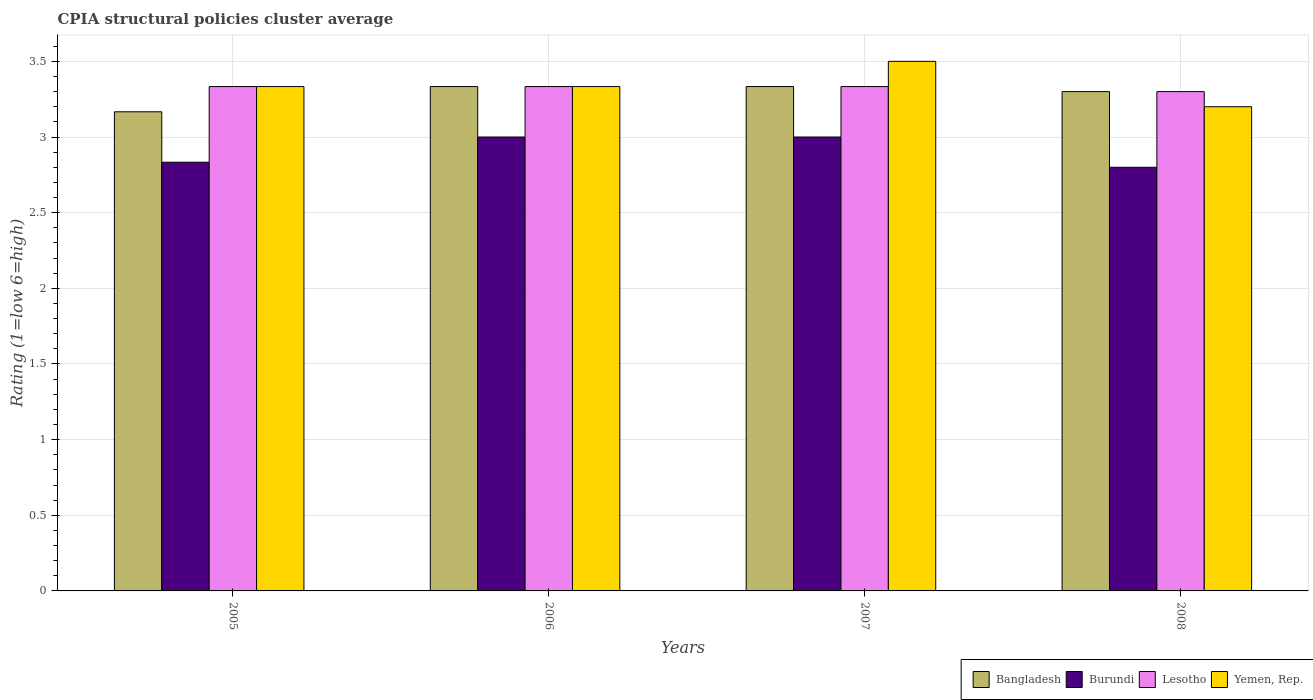How many groups of bars are there?
Make the answer very short. 4. Are the number of bars on each tick of the X-axis equal?
Provide a short and direct response. Yes. How many bars are there on the 3rd tick from the right?
Your answer should be compact. 4. In how many cases, is the number of bars for a given year not equal to the number of legend labels?
Make the answer very short. 0. What is the CPIA rating in Lesotho in 2007?
Keep it short and to the point. 3.33. Across all years, what is the maximum CPIA rating in Bangladesh?
Give a very brief answer. 3.33. Across all years, what is the minimum CPIA rating in Bangladesh?
Offer a terse response. 3.17. In which year was the CPIA rating in Lesotho minimum?
Your answer should be compact. 2008. What is the total CPIA rating in Yemen, Rep. in the graph?
Keep it short and to the point. 13.37. What is the difference between the CPIA rating in Bangladesh in 2005 and that in 2007?
Your response must be concise. -0.17. What is the difference between the CPIA rating in Yemen, Rep. in 2007 and the CPIA rating in Lesotho in 2006?
Offer a very short reply. 0.17. What is the average CPIA rating in Yemen, Rep. per year?
Offer a very short reply. 3.34. What is the ratio of the CPIA rating in Lesotho in 2005 to that in 2008?
Provide a short and direct response. 1.01. What is the difference between the highest and the lowest CPIA rating in Bangladesh?
Your answer should be compact. 0.17. In how many years, is the CPIA rating in Lesotho greater than the average CPIA rating in Lesotho taken over all years?
Offer a terse response. 3. Is the sum of the CPIA rating in Bangladesh in 2005 and 2008 greater than the maximum CPIA rating in Yemen, Rep. across all years?
Keep it short and to the point. Yes. What does the 2nd bar from the left in 2008 represents?
Ensure brevity in your answer.  Burundi. What does the 3rd bar from the right in 2005 represents?
Your response must be concise. Burundi. Is it the case that in every year, the sum of the CPIA rating in Lesotho and CPIA rating in Yemen, Rep. is greater than the CPIA rating in Burundi?
Your answer should be compact. Yes. How many bars are there?
Make the answer very short. 16. Are all the bars in the graph horizontal?
Ensure brevity in your answer.  No. What is the difference between two consecutive major ticks on the Y-axis?
Ensure brevity in your answer.  0.5. Are the values on the major ticks of Y-axis written in scientific E-notation?
Keep it short and to the point. No. Does the graph contain any zero values?
Offer a very short reply. No. Does the graph contain grids?
Your answer should be compact. Yes. How many legend labels are there?
Give a very brief answer. 4. How are the legend labels stacked?
Give a very brief answer. Horizontal. What is the title of the graph?
Your answer should be very brief. CPIA structural policies cluster average. What is the label or title of the X-axis?
Offer a terse response. Years. What is the Rating (1=low 6=high) in Bangladesh in 2005?
Provide a short and direct response. 3.17. What is the Rating (1=low 6=high) of Burundi in 2005?
Provide a short and direct response. 2.83. What is the Rating (1=low 6=high) of Lesotho in 2005?
Your answer should be very brief. 3.33. What is the Rating (1=low 6=high) of Yemen, Rep. in 2005?
Offer a terse response. 3.33. What is the Rating (1=low 6=high) of Bangladesh in 2006?
Provide a short and direct response. 3.33. What is the Rating (1=low 6=high) in Burundi in 2006?
Make the answer very short. 3. What is the Rating (1=low 6=high) of Lesotho in 2006?
Keep it short and to the point. 3.33. What is the Rating (1=low 6=high) in Yemen, Rep. in 2006?
Your answer should be compact. 3.33. What is the Rating (1=low 6=high) in Bangladesh in 2007?
Offer a terse response. 3.33. What is the Rating (1=low 6=high) of Lesotho in 2007?
Ensure brevity in your answer.  3.33. What is the Rating (1=low 6=high) in Burundi in 2008?
Give a very brief answer. 2.8. What is the Rating (1=low 6=high) of Yemen, Rep. in 2008?
Your response must be concise. 3.2. Across all years, what is the maximum Rating (1=low 6=high) of Bangladesh?
Your answer should be very brief. 3.33. Across all years, what is the maximum Rating (1=low 6=high) in Burundi?
Provide a succinct answer. 3. Across all years, what is the maximum Rating (1=low 6=high) in Lesotho?
Offer a terse response. 3.33. Across all years, what is the maximum Rating (1=low 6=high) in Yemen, Rep.?
Provide a succinct answer. 3.5. Across all years, what is the minimum Rating (1=low 6=high) in Bangladesh?
Give a very brief answer. 3.17. Across all years, what is the minimum Rating (1=low 6=high) in Yemen, Rep.?
Provide a short and direct response. 3.2. What is the total Rating (1=low 6=high) in Bangladesh in the graph?
Keep it short and to the point. 13.13. What is the total Rating (1=low 6=high) in Burundi in the graph?
Offer a very short reply. 11.63. What is the total Rating (1=low 6=high) in Yemen, Rep. in the graph?
Your answer should be compact. 13.37. What is the difference between the Rating (1=low 6=high) in Yemen, Rep. in 2005 and that in 2006?
Your answer should be very brief. 0. What is the difference between the Rating (1=low 6=high) in Bangladesh in 2005 and that in 2007?
Offer a terse response. -0.17. What is the difference between the Rating (1=low 6=high) of Lesotho in 2005 and that in 2007?
Provide a short and direct response. 0. What is the difference between the Rating (1=low 6=high) of Yemen, Rep. in 2005 and that in 2007?
Your response must be concise. -0.17. What is the difference between the Rating (1=low 6=high) of Bangladesh in 2005 and that in 2008?
Offer a very short reply. -0.13. What is the difference between the Rating (1=low 6=high) of Burundi in 2005 and that in 2008?
Your response must be concise. 0.03. What is the difference between the Rating (1=low 6=high) of Yemen, Rep. in 2005 and that in 2008?
Ensure brevity in your answer.  0.13. What is the difference between the Rating (1=low 6=high) in Bangladesh in 2006 and that in 2007?
Offer a terse response. 0. What is the difference between the Rating (1=low 6=high) in Yemen, Rep. in 2006 and that in 2007?
Your response must be concise. -0.17. What is the difference between the Rating (1=low 6=high) in Bangladesh in 2006 and that in 2008?
Your answer should be very brief. 0.03. What is the difference between the Rating (1=low 6=high) of Yemen, Rep. in 2006 and that in 2008?
Ensure brevity in your answer.  0.13. What is the difference between the Rating (1=low 6=high) in Bangladesh in 2007 and that in 2008?
Provide a short and direct response. 0.03. What is the difference between the Rating (1=low 6=high) in Yemen, Rep. in 2007 and that in 2008?
Your answer should be very brief. 0.3. What is the difference between the Rating (1=low 6=high) in Bangladesh in 2005 and the Rating (1=low 6=high) in Burundi in 2006?
Provide a short and direct response. 0.17. What is the difference between the Rating (1=low 6=high) of Bangladesh in 2005 and the Rating (1=low 6=high) of Burundi in 2007?
Ensure brevity in your answer.  0.17. What is the difference between the Rating (1=low 6=high) in Lesotho in 2005 and the Rating (1=low 6=high) in Yemen, Rep. in 2007?
Provide a short and direct response. -0.17. What is the difference between the Rating (1=low 6=high) in Bangladesh in 2005 and the Rating (1=low 6=high) in Burundi in 2008?
Keep it short and to the point. 0.37. What is the difference between the Rating (1=low 6=high) in Bangladesh in 2005 and the Rating (1=low 6=high) in Lesotho in 2008?
Your response must be concise. -0.13. What is the difference between the Rating (1=low 6=high) of Bangladesh in 2005 and the Rating (1=low 6=high) of Yemen, Rep. in 2008?
Offer a very short reply. -0.03. What is the difference between the Rating (1=low 6=high) of Burundi in 2005 and the Rating (1=low 6=high) of Lesotho in 2008?
Ensure brevity in your answer.  -0.47. What is the difference between the Rating (1=low 6=high) of Burundi in 2005 and the Rating (1=low 6=high) of Yemen, Rep. in 2008?
Offer a terse response. -0.37. What is the difference between the Rating (1=low 6=high) of Lesotho in 2005 and the Rating (1=low 6=high) of Yemen, Rep. in 2008?
Ensure brevity in your answer.  0.13. What is the difference between the Rating (1=low 6=high) of Bangladesh in 2006 and the Rating (1=low 6=high) of Yemen, Rep. in 2007?
Ensure brevity in your answer.  -0.17. What is the difference between the Rating (1=low 6=high) of Bangladesh in 2006 and the Rating (1=low 6=high) of Burundi in 2008?
Your response must be concise. 0.53. What is the difference between the Rating (1=low 6=high) in Bangladesh in 2006 and the Rating (1=low 6=high) in Yemen, Rep. in 2008?
Offer a very short reply. 0.13. What is the difference between the Rating (1=low 6=high) of Lesotho in 2006 and the Rating (1=low 6=high) of Yemen, Rep. in 2008?
Ensure brevity in your answer.  0.13. What is the difference between the Rating (1=low 6=high) of Bangladesh in 2007 and the Rating (1=low 6=high) of Burundi in 2008?
Offer a very short reply. 0.53. What is the difference between the Rating (1=low 6=high) in Bangladesh in 2007 and the Rating (1=low 6=high) in Yemen, Rep. in 2008?
Provide a succinct answer. 0.13. What is the difference between the Rating (1=low 6=high) of Burundi in 2007 and the Rating (1=low 6=high) of Lesotho in 2008?
Provide a short and direct response. -0.3. What is the difference between the Rating (1=low 6=high) of Burundi in 2007 and the Rating (1=low 6=high) of Yemen, Rep. in 2008?
Ensure brevity in your answer.  -0.2. What is the difference between the Rating (1=low 6=high) of Lesotho in 2007 and the Rating (1=low 6=high) of Yemen, Rep. in 2008?
Give a very brief answer. 0.13. What is the average Rating (1=low 6=high) in Bangladesh per year?
Give a very brief answer. 3.28. What is the average Rating (1=low 6=high) of Burundi per year?
Offer a very short reply. 2.91. What is the average Rating (1=low 6=high) of Lesotho per year?
Your answer should be very brief. 3.33. What is the average Rating (1=low 6=high) of Yemen, Rep. per year?
Offer a terse response. 3.34. In the year 2005, what is the difference between the Rating (1=low 6=high) in Bangladesh and Rating (1=low 6=high) in Burundi?
Make the answer very short. 0.33. In the year 2005, what is the difference between the Rating (1=low 6=high) in Bangladesh and Rating (1=low 6=high) in Yemen, Rep.?
Offer a very short reply. -0.17. In the year 2005, what is the difference between the Rating (1=low 6=high) of Burundi and Rating (1=low 6=high) of Lesotho?
Your answer should be very brief. -0.5. In the year 2005, what is the difference between the Rating (1=low 6=high) in Lesotho and Rating (1=low 6=high) in Yemen, Rep.?
Offer a very short reply. 0. In the year 2006, what is the difference between the Rating (1=low 6=high) of Bangladesh and Rating (1=low 6=high) of Burundi?
Provide a succinct answer. 0.33. In the year 2006, what is the difference between the Rating (1=low 6=high) in Bangladesh and Rating (1=low 6=high) in Yemen, Rep.?
Make the answer very short. 0. In the year 2006, what is the difference between the Rating (1=low 6=high) of Burundi and Rating (1=low 6=high) of Yemen, Rep.?
Provide a short and direct response. -0.33. In the year 2006, what is the difference between the Rating (1=low 6=high) of Lesotho and Rating (1=low 6=high) of Yemen, Rep.?
Your response must be concise. 0. In the year 2007, what is the difference between the Rating (1=low 6=high) in Bangladesh and Rating (1=low 6=high) in Lesotho?
Give a very brief answer. 0. In the year 2007, what is the difference between the Rating (1=low 6=high) of Burundi and Rating (1=low 6=high) of Lesotho?
Ensure brevity in your answer.  -0.33. In the year 2007, what is the difference between the Rating (1=low 6=high) of Lesotho and Rating (1=low 6=high) of Yemen, Rep.?
Ensure brevity in your answer.  -0.17. In the year 2008, what is the difference between the Rating (1=low 6=high) in Bangladesh and Rating (1=low 6=high) in Burundi?
Ensure brevity in your answer.  0.5. In the year 2008, what is the difference between the Rating (1=low 6=high) of Bangladesh and Rating (1=low 6=high) of Lesotho?
Your answer should be compact. 0. In the year 2008, what is the difference between the Rating (1=low 6=high) in Bangladesh and Rating (1=low 6=high) in Yemen, Rep.?
Ensure brevity in your answer.  0.1. What is the ratio of the Rating (1=low 6=high) in Bangladesh in 2005 to that in 2006?
Provide a short and direct response. 0.95. What is the ratio of the Rating (1=low 6=high) of Burundi in 2005 to that in 2006?
Offer a very short reply. 0.94. What is the ratio of the Rating (1=low 6=high) in Yemen, Rep. in 2005 to that in 2006?
Ensure brevity in your answer.  1. What is the ratio of the Rating (1=low 6=high) of Bangladesh in 2005 to that in 2007?
Give a very brief answer. 0.95. What is the ratio of the Rating (1=low 6=high) in Burundi in 2005 to that in 2007?
Provide a succinct answer. 0.94. What is the ratio of the Rating (1=low 6=high) of Yemen, Rep. in 2005 to that in 2007?
Offer a terse response. 0.95. What is the ratio of the Rating (1=low 6=high) in Bangladesh in 2005 to that in 2008?
Offer a terse response. 0.96. What is the ratio of the Rating (1=low 6=high) of Burundi in 2005 to that in 2008?
Offer a very short reply. 1.01. What is the ratio of the Rating (1=low 6=high) in Lesotho in 2005 to that in 2008?
Give a very brief answer. 1.01. What is the ratio of the Rating (1=low 6=high) of Yemen, Rep. in 2005 to that in 2008?
Provide a short and direct response. 1.04. What is the ratio of the Rating (1=low 6=high) in Bangladesh in 2006 to that in 2007?
Keep it short and to the point. 1. What is the ratio of the Rating (1=low 6=high) in Burundi in 2006 to that in 2007?
Make the answer very short. 1. What is the ratio of the Rating (1=low 6=high) of Lesotho in 2006 to that in 2007?
Your answer should be very brief. 1. What is the ratio of the Rating (1=low 6=high) in Yemen, Rep. in 2006 to that in 2007?
Provide a succinct answer. 0.95. What is the ratio of the Rating (1=low 6=high) in Burundi in 2006 to that in 2008?
Provide a succinct answer. 1.07. What is the ratio of the Rating (1=low 6=high) in Yemen, Rep. in 2006 to that in 2008?
Ensure brevity in your answer.  1.04. What is the ratio of the Rating (1=low 6=high) of Burundi in 2007 to that in 2008?
Your response must be concise. 1.07. What is the ratio of the Rating (1=low 6=high) of Lesotho in 2007 to that in 2008?
Give a very brief answer. 1.01. What is the ratio of the Rating (1=low 6=high) in Yemen, Rep. in 2007 to that in 2008?
Your answer should be compact. 1.09. What is the difference between the highest and the lowest Rating (1=low 6=high) of Bangladesh?
Your answer should be very brief. 0.17. What is the difference between the highest and the lowest Rating (1=low 6=high) in Burundi?
Your answer should be very brief. 0.2. What is the difference between the highest and the lowest Rating (1=low 6=high) of Lesotho?
Your response must be concise. 0.03. 